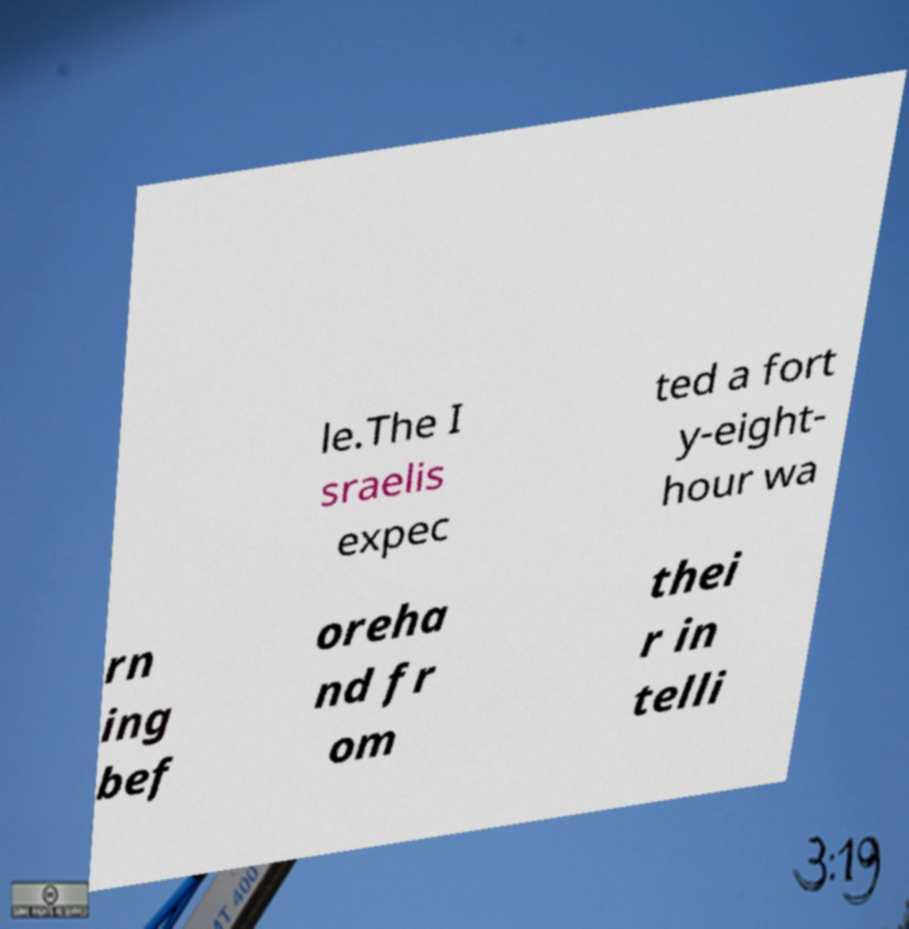Could you extract and type out the text from this image? le.The I sraelis expec ted a fort y-eight- hour wa rn ing bef oreha nd fr om thei r in telli 